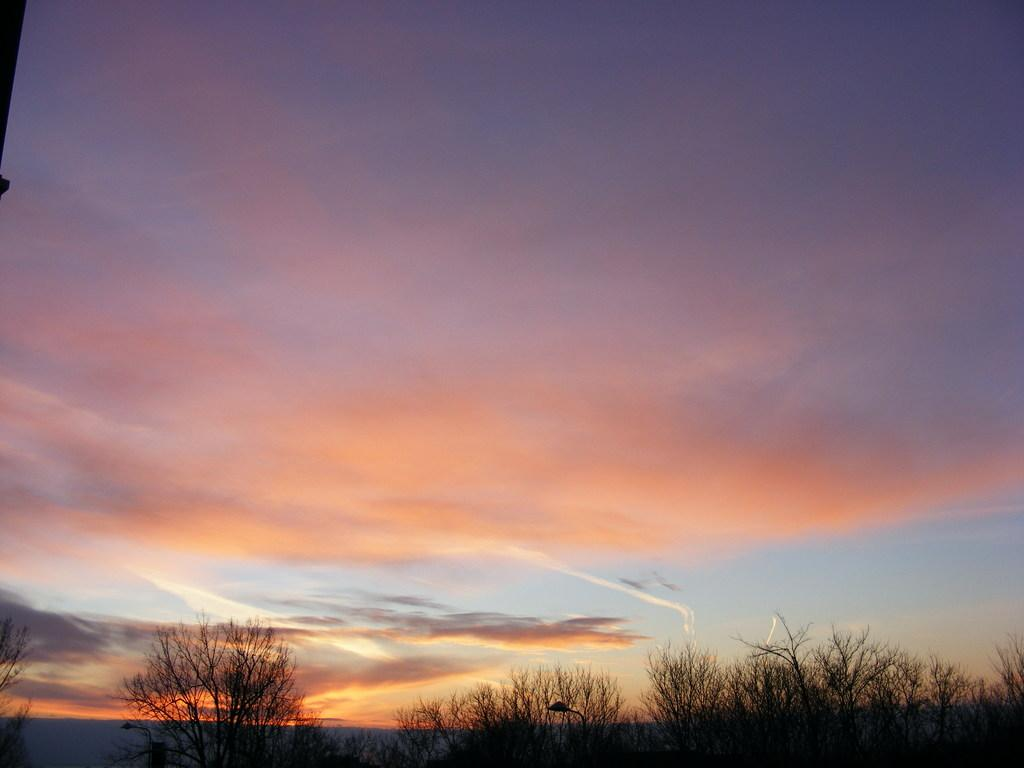What type of vegetation can be seen in the image? There are trees in the image. What structure is visible in the image? There is a light pole in the image. What is visible in the background of the image? The sky is visible in the image. What can be seen in the sky? Clouds are present in the sky. How much salt is on the leaves of the trees in the image? There is no mention of salt or any substance on the leaves of the trees in the image. Can you describe the beetle crawling on the light pole in the image? There is no beetle present on the light pole or anywhere else in the image. 